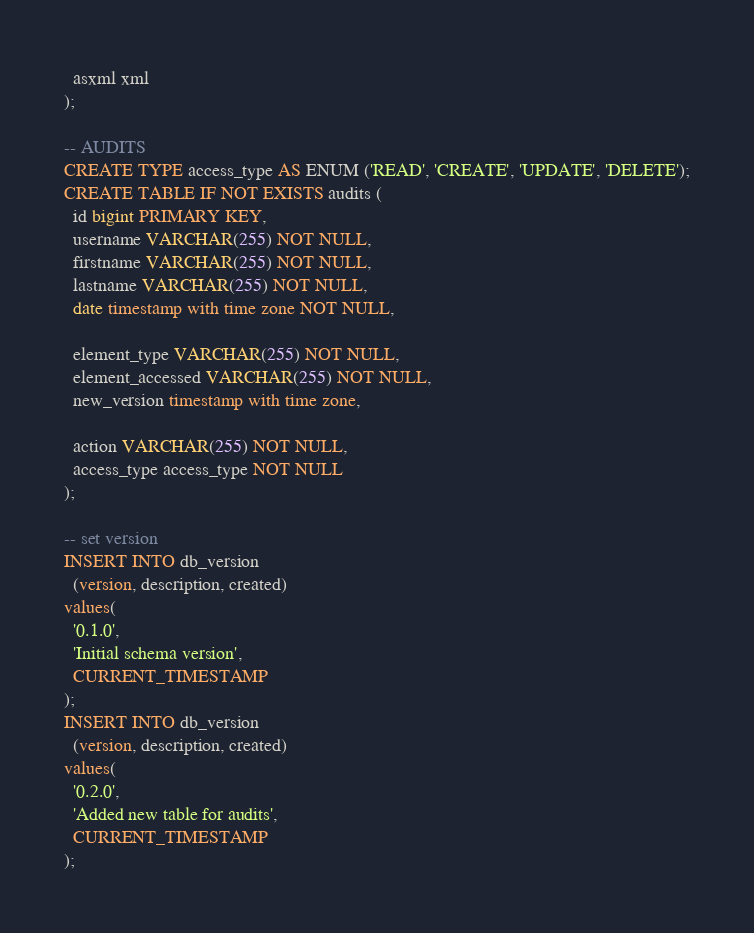Convert code to text. <code><loc_0><loc_0><loc_500><loc_500><_SQL_>  asxml xml
);

-- AUDITS
CREATE TYPE access_type AS ENUM ('READ', 'CREATE', 'UPDATE', 'DELETE');
CREATE TABLE IF NOT EXISTS audits (
  id bigint PRIMARY KEY,
  username VARCHAR(255) NOT NULL,
  firstname VARCHAR(255) NOT NULL,
  lastname VARCHAR(255) NOT NULL,
  date timestamp with time zone NOT NULL,

  element_type VARCHAR(255) NOT NULL,
  element_accessed VARCHAR(255) NOT NULL,
  new_version timestamp with time zone,

  action VARCHAR(255) NOT NULL,
  access_type access_type NOT NULL
);

-- set version
INSERT INTO db_version 
  (version, description, created) 
values(
  '0.1.0',
  'Initial schema version',
  CURRENT_TIMESTAMP
);
INSERT INTO db_version 
  (version, description, created) 
values(
  '0.2.0',
  'Added new table for audits',
  CURRENT_TIMESTAMP
);
</code> 